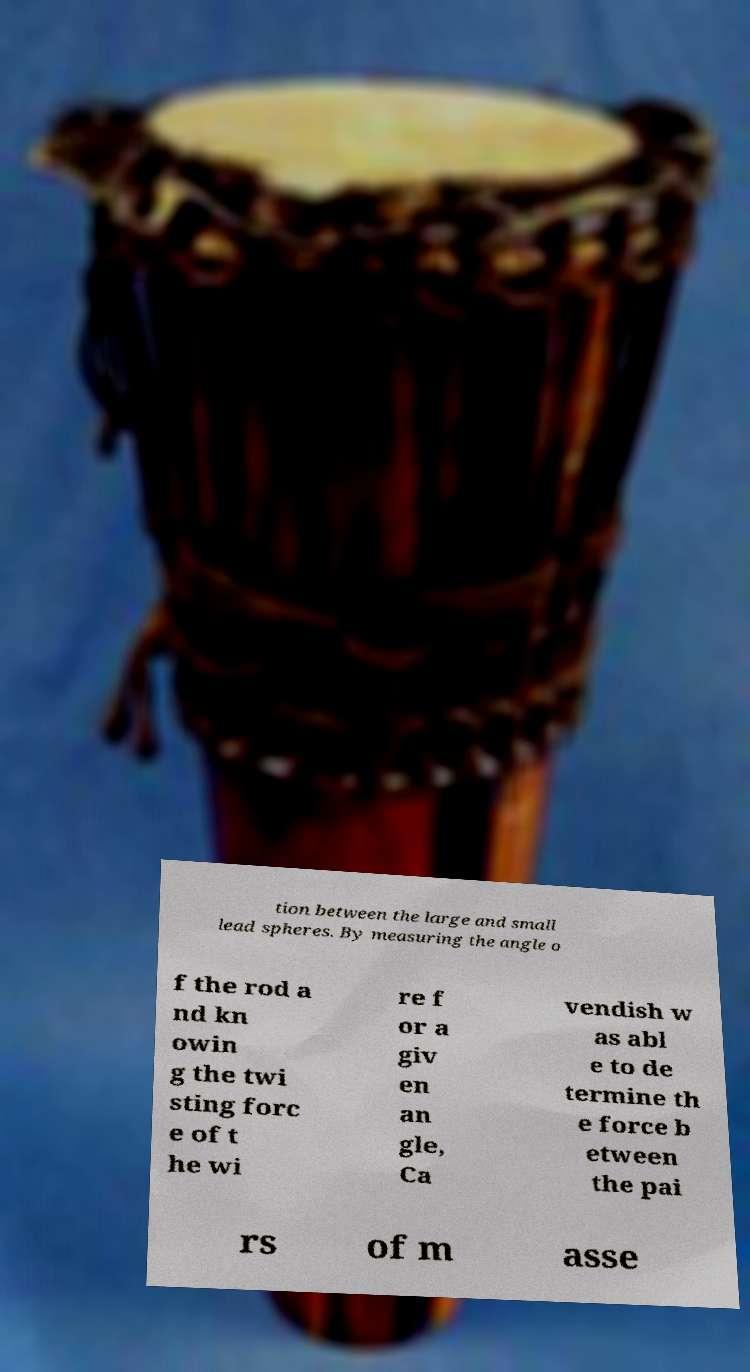Please identify and transcribe the text found in this image. tion between the large and small lead spheres. By measuring the angle o f the rod a nd kn owin g the twi sting forc e of t he wi re f or a giv en an gle, Ca vendish w as abl e to de termine th e force b etween the pai rs of m asse 